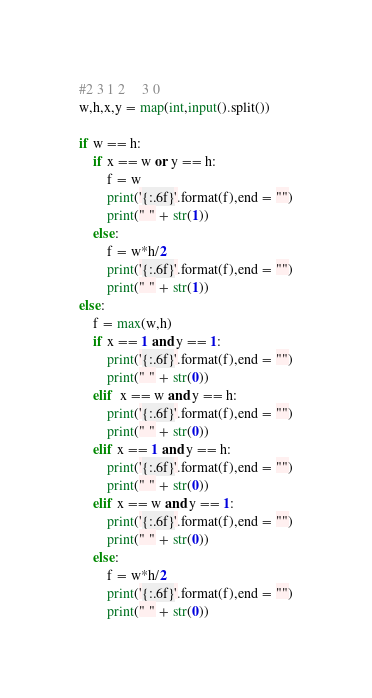Convert code to text. <code><loc_0><loc_0><loc_500><loc_500><_Python_>#2 3 1 2     3 0
w,h,x,y = map(int,input().split())

if w == h:
    if x == w or y == h:
        f = w
        print('{:.6f}'.format(f),end = "")
        print(" " + str(1))
    else:  
        f = w*h/2
        print('{:.6f}'.format(f),end = "")
        print(" " + str(1))
else:
    f = max(w,h)
    if x == 1 and y == 1:
        print('{:.6f}'.format(f),end = "")
        print(" " + str(0))
    elif  x == w and y == h:
        print('{:.6f}'.format(f),end = "")
        print(" " + str(0))
    elif x == 1 and y == h:
        print('{:.6f}'.format(f),end = "")
        print(" " + str(0))
    elif x == w and y == 1:
        print('{:.6f}'.format(f),end = "")
        print(" " + str(0))
    else:
        f = w*h/2
        print('{:.6f}'.format(f),end = "")
        print(" " + str(0))



</code> 